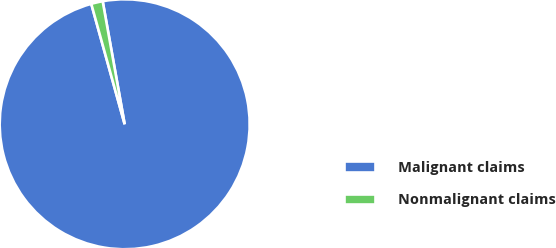Convert chart. <chart><loc_0><loc_0><loc_500><loc_500><pie_chart><fcel>Malignant claims<fcel>Nonmalignant claims<nl><fcel>98.51%<fcel>1.49%<nl></chart> 